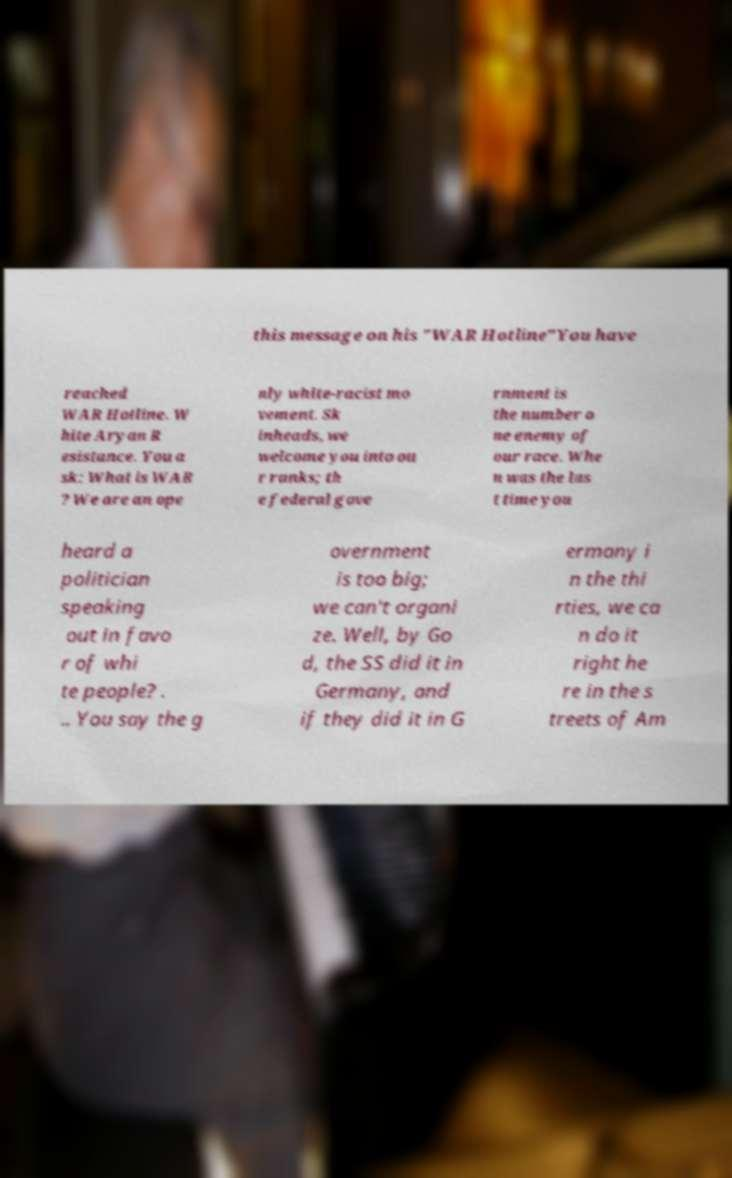I need the written content from this picture converted into text. Can you do that? this message on his "WAR Hotline"You have reached WAR Hotline. W hite Aryan R esistance. You a sk: What is WAR ? We are an ope nly white-racist mo vement. Sk inheads, we welcome you into ou r ranks; th e federal gove rnment is the number o ne enemy of our race. Whe n was the las t time you heard a politician speaking out in favo r of whi te people? . .. You say the g overnment is too big; we can't organi ze. Well, by Go d, the SS did it in Germany, and if they did it in G ermany i n the thi rties, we ca n do it right he re in the s treets of Am 